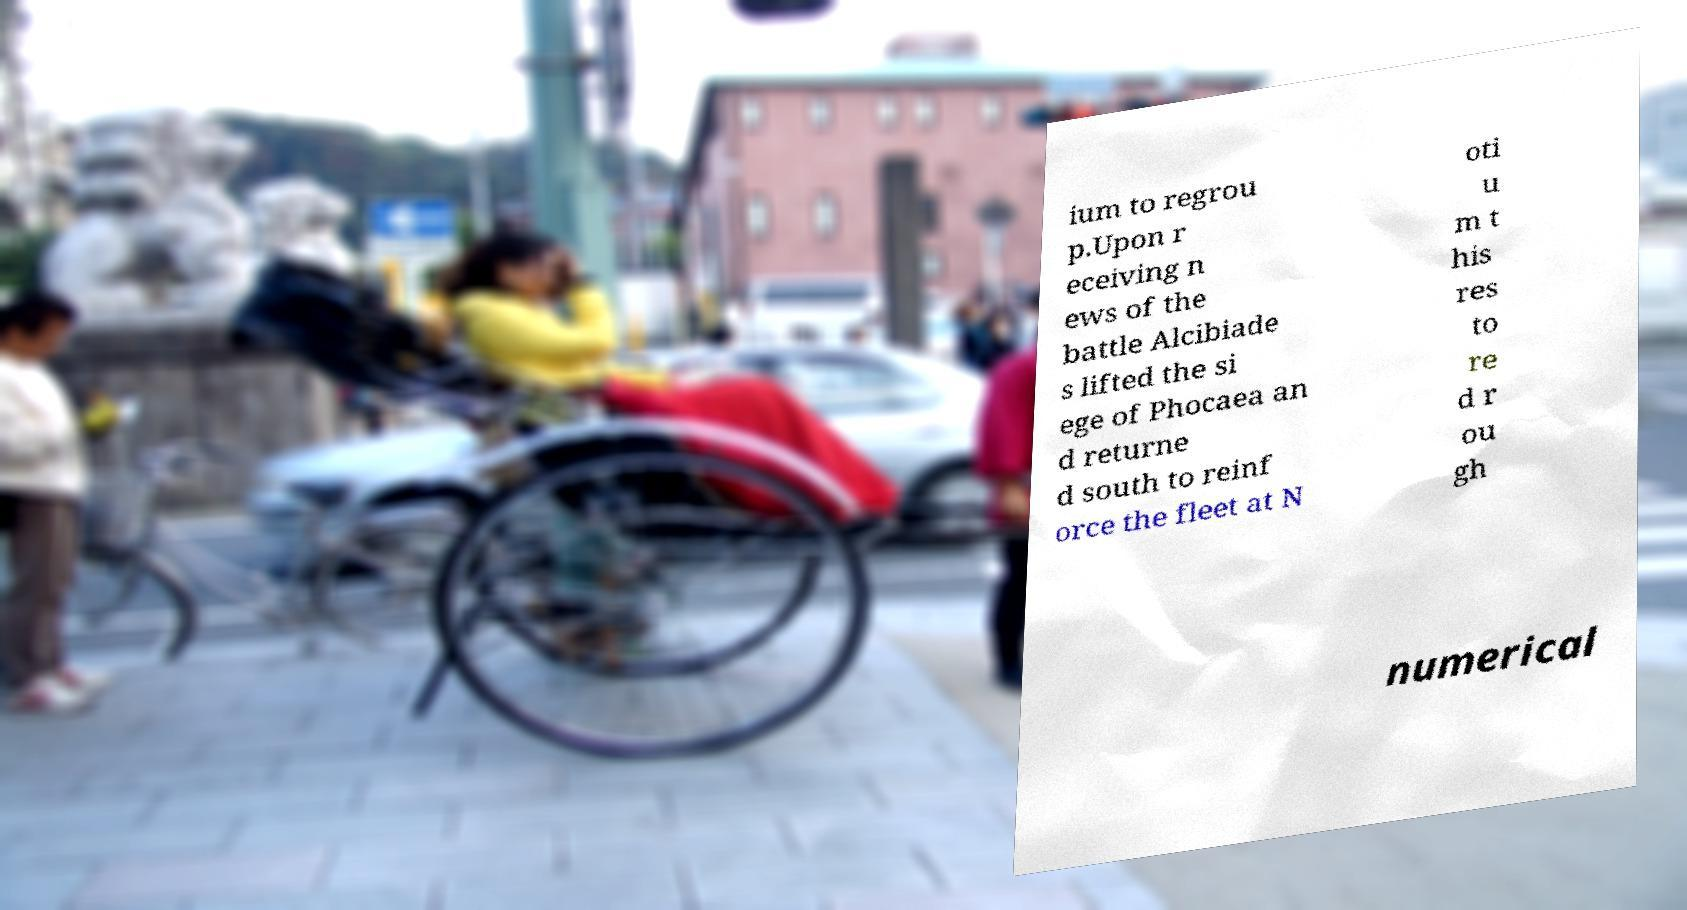There's text embedded in this image that I need extracted. Can you transcribe it verbatim? ium to regrou p.Upon r eceiving n ews of the battle Alcibiade s lifted the si ege of Phocaea an d returne d south to reinf orce the fleet at N oti u m t his res to re d r ou gh numerical 